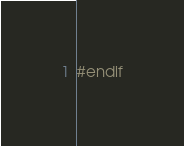<code> <loc_0><loc_0><loc_500><loc_500><_C_>#endif
</code> 